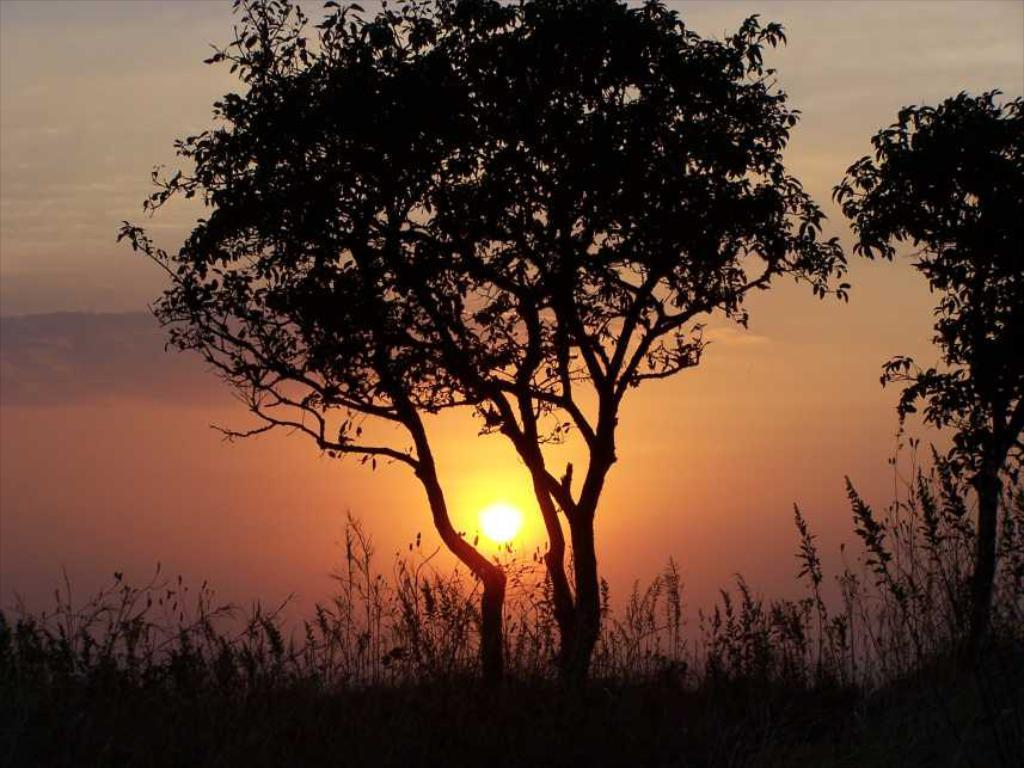What is the main celestial body in the image? The sun is in the center of the image. What type of vegetation can be seen in the image? There are trees and plants visible in the image. What part of the natural environment is visible at the top of the image? The sky is visible at the top of the image. What type of education is being discussed in the image? There is no discussion or education present in the image; it features the sun, trees, plants, and the sky. What type of operation is being performed on the tree in the image? There is no operation being performed on the tree in the image; it is simply a tree in its natural state. 